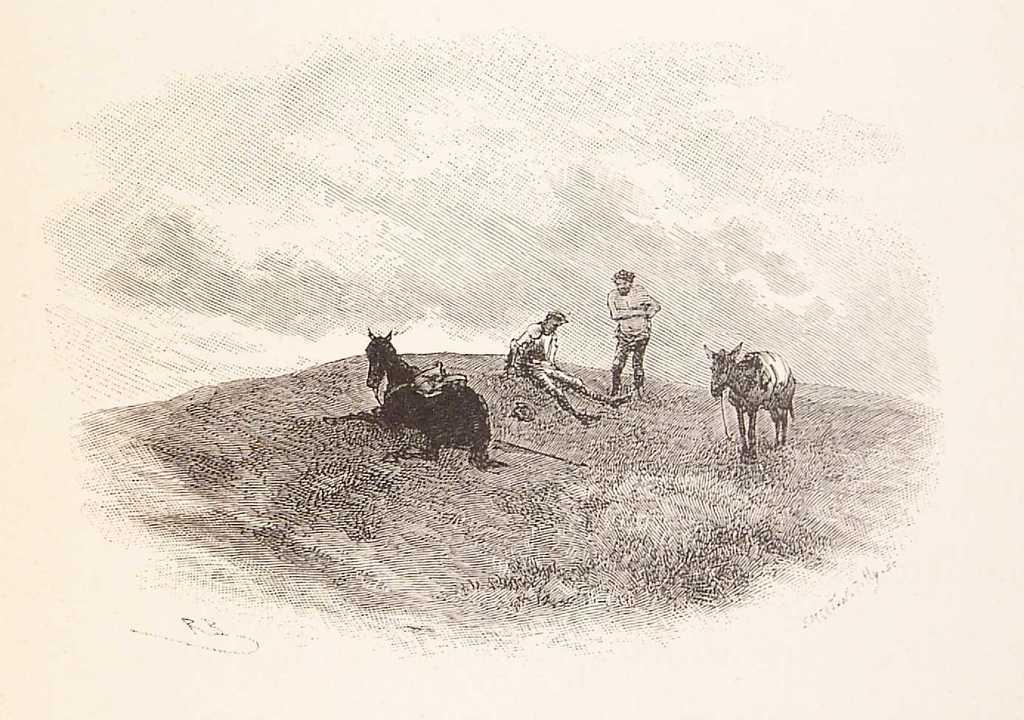How many animals are present in the image? There are two animals in the image. How many people are present in the image? There are two persons in the image. What is the color scheme of the image? The image is in black and white. What type of elbow can be seen in the image? There is no elbow present in the image. Is there an oven visible in the image? There is no oven present in the image. 